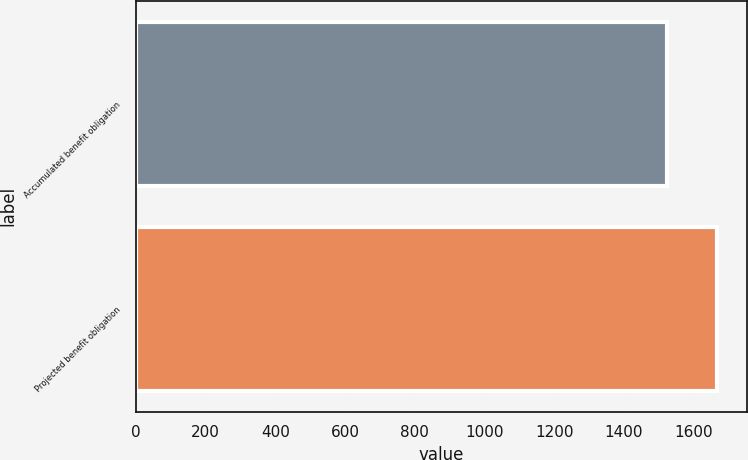Convert chart to OTSL. <chart><loc_0><loc_0><loc_500><loc_500><bar_chart><fcel>Accumulated benefit obligation<fcel>Projected benefit obligation<nl><fcel>1523.9<fcel>1667.9<nl></chart> 